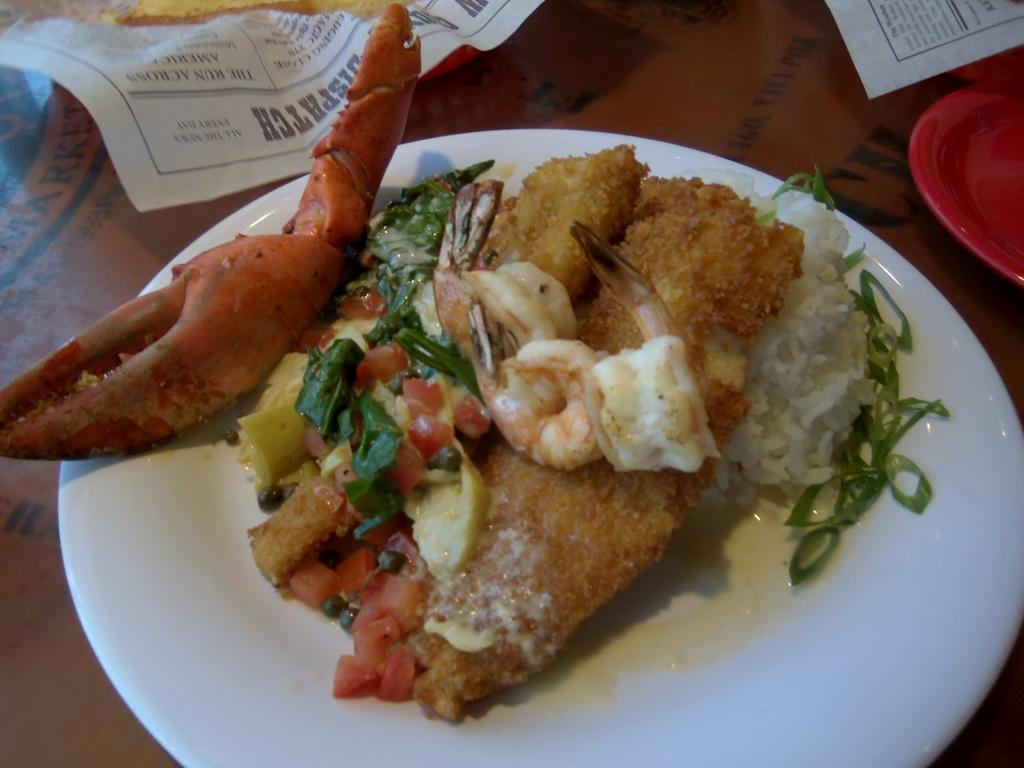What type of food is on the plate in the image? There is a plate containing lobster and rice in the image. What else can be seen in the image besides the food? There are papers and another plate beside the image. Where are all the items in the image located? All items are placed on a table. What type of song is being sung by the farmer in the hall in the image? There is no farmer, hall, or song present in the image. 